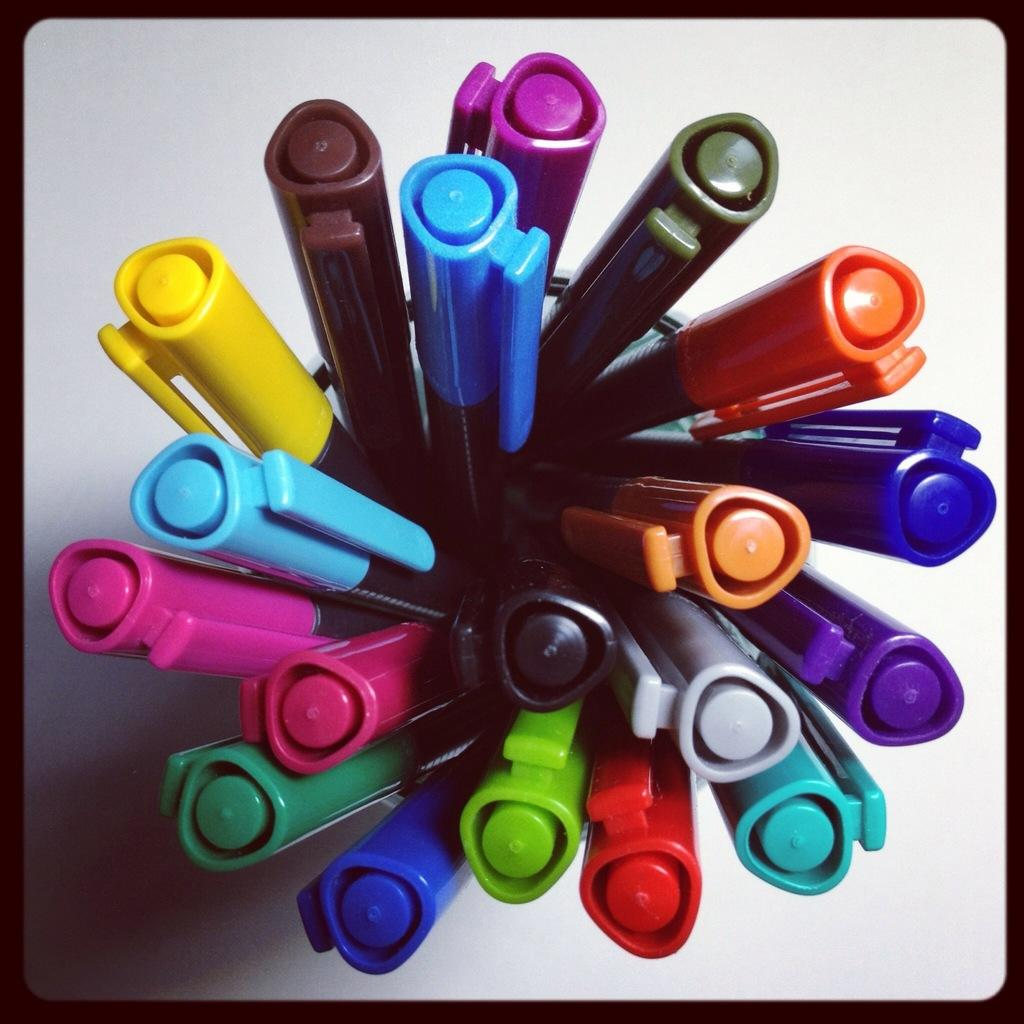How many spoons are being used to put out the fire in the bucket in the image? There is no fire or bucket present in the image, so it is not possible to answer that question. 